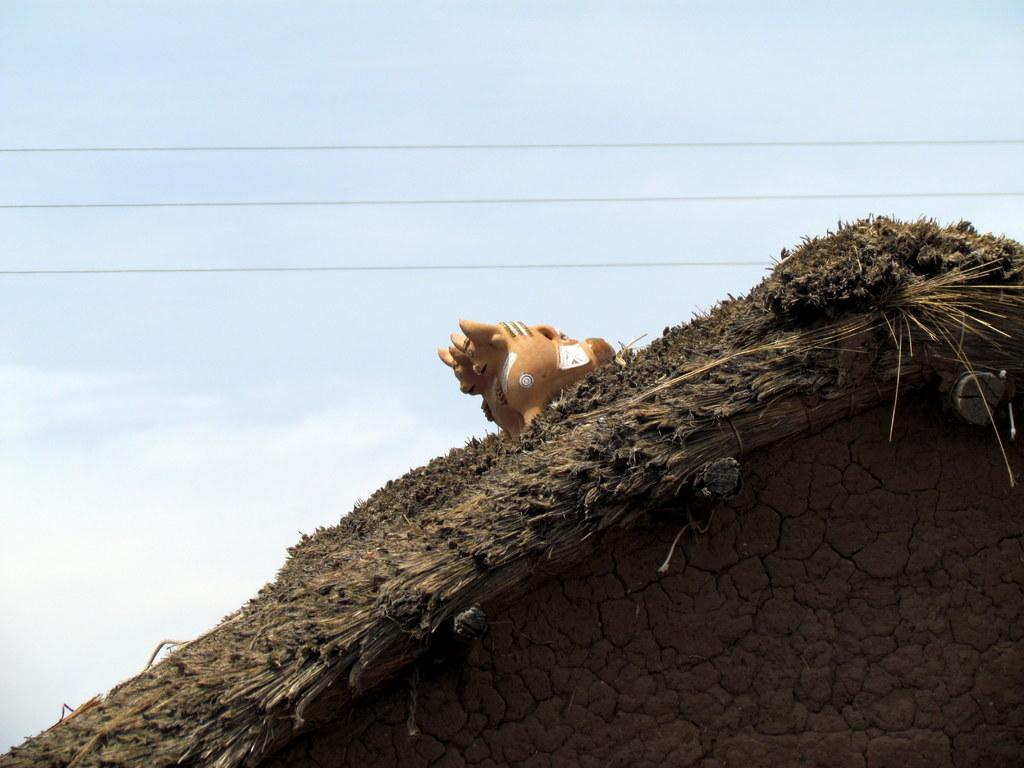What type of structure is present in the image? There is a hut in the image. What is on top of the hut? There is a toy on the roof of the hut. What can be seen in the background of the image? Wires and the sky are visible in the background of the image. What type of pollution can be seen in the image? There is no visible pollution in the image. What button is being pressed by the person in the image? There is no person or button present in the image. 